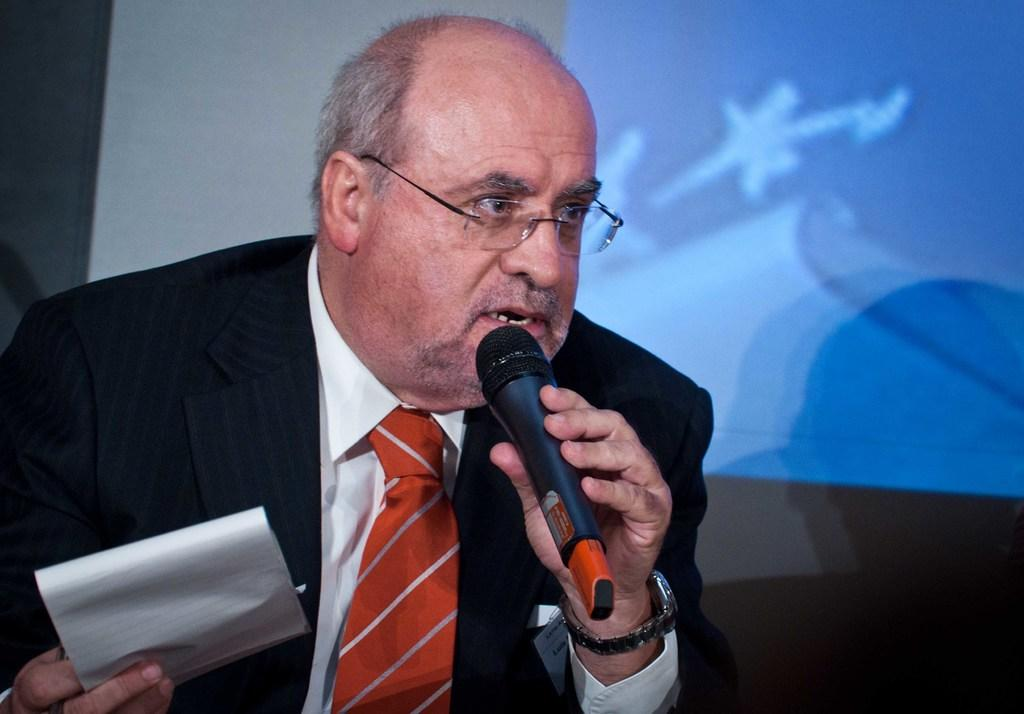Who is present in the image? There is a person in the image. What is the person holding in the image? The person is holding a microphone. What is the person doing in the image? The person is speaking. What can be seen in the background of the image? There is a screen in the background of the image. Can you see any visible veins on the person's hand in the image? There is no information about the person's hand or veins in the image, so it cannot be determined. 